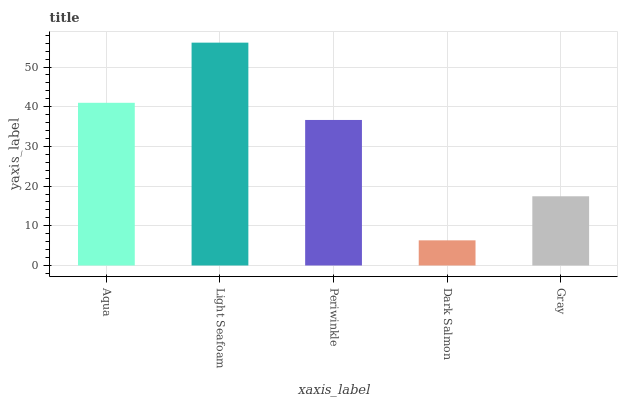Is Periwinkle the minimum?
Answer yes or no. No. Is Periwinkle the maximum?
Answer yes or no. No. Is Light Seafoam greater than Periwinkle?
Answer yes or no. Yes. Is Periwinkle less than Light Seafoam?
Answer yes or no. Yes. Is Periwinkle greater than Light Seafoam?
Answer yes or no. No. Is Light Seafoam less than Periwinkle?
Answer yes or no. No. Is Periwinkle the high median?
Answer yes or no. Yes. Is Periwinkle the low median?
Answer yes or no. Yes. Is Aqua the high median?
Answer yes or no. No. Is Gray the low median?
Answer yes or no. No. 